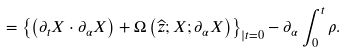Convert formula to latex. <formula><loc_0><loc_0><loc_500><loc_500>= \left \{ \left ( \partial _ { t } X \cdot \partial _ { \alpha } X \right ) + \Omega \left ( { \widehat { z } } ; X ; \partial _ { \alpha } X \right ) \right \} _ { | t = 0 } - \partial _ { \alpha } \int _ { 0 } ^ { t } \rho .</formula> 